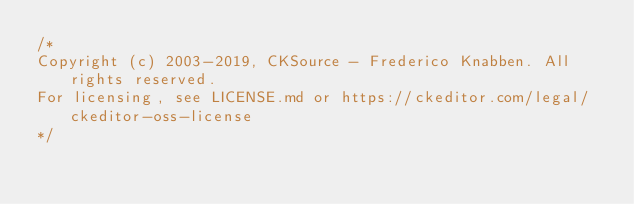Convert code to text. <code><loc_0><loc_0><loc_500><loc_500><_CSS_>/*
Copyright (c) 2003-2019, CKSource - Frederico Knabben. All rights reserved.
For licensing, see LICENSE.md or https://ckeditor.com/legal/ckeditor-oss-license
*/</code> 